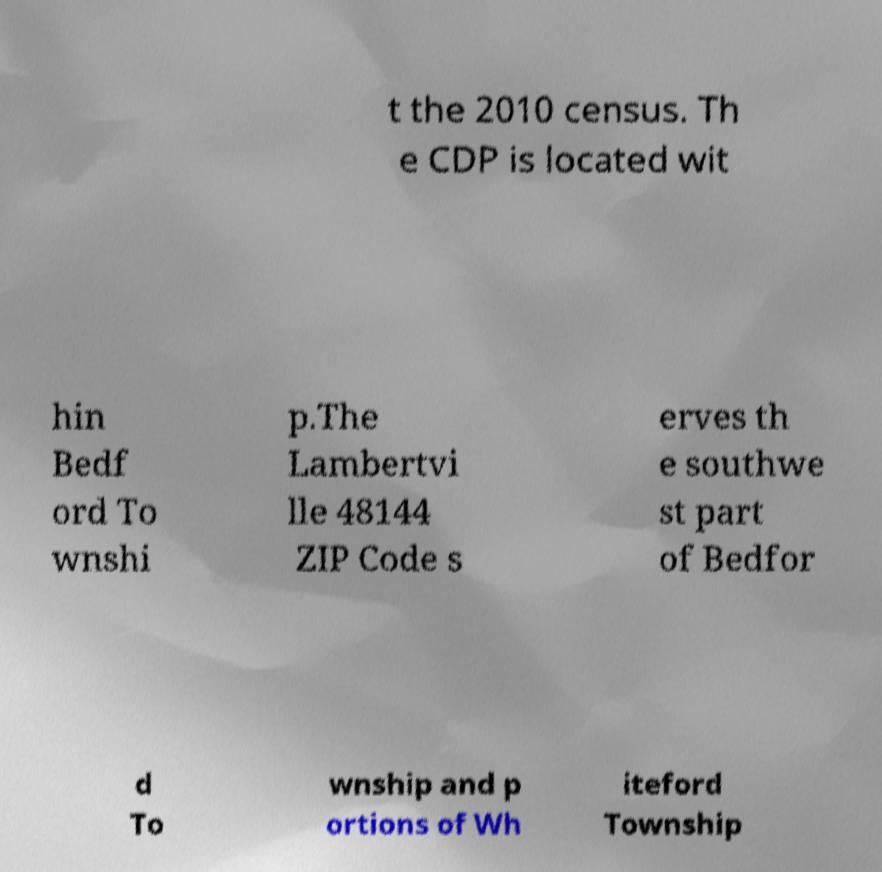Can you read and provide the text displayed in the image?This photo seems to have some interesting text. Can you extract and type it out for me? t the 2010 census. Th e CDP is located wit hin Bedf ord To wnshi p.The Lambertvi lle 48144 ZIP Code s erves th e southwe st part of Bedfor d To wnship and p ortions of Wh iteford Township 